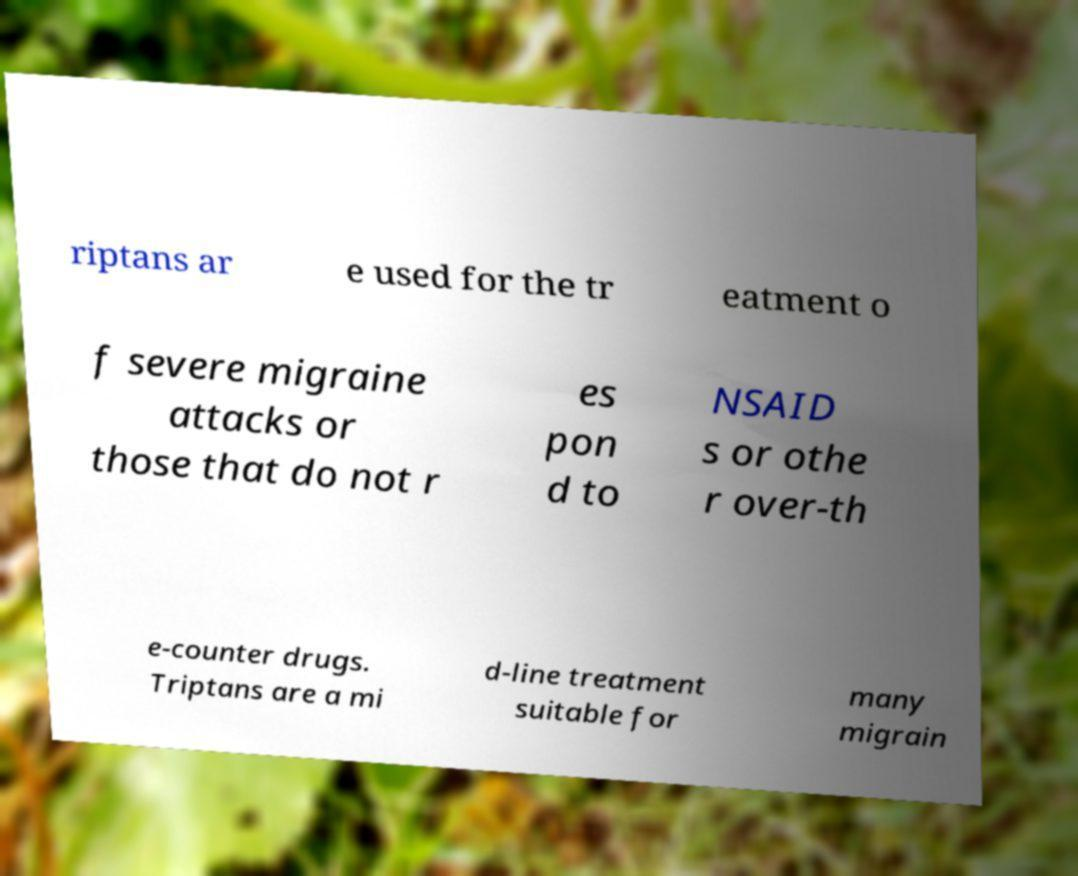Please identify and transcribe the text found in this image. riptans ar e used for the tr eatment o f severe migraine attacks or those that do not r es pon d to NSAID s or othe r over-th e-counter drugs. Triptans are a mi d-line treatment suitable for many migrain 